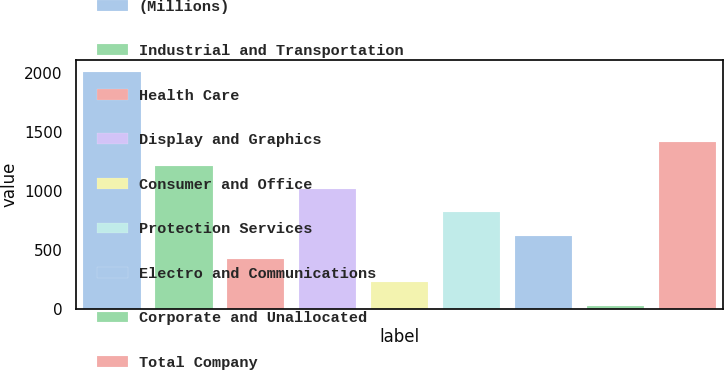<chart> <loc_0><loc_0><loc_500><loc_500><bar_chart><fcel>(Millions)<fcel>Industrial and Transportation<fcel>Health Care<fcel>Display and Graphics<fcel>Consumer and Office<fcel>Protection Services<fcel>Electro and Communications<fcel>Corporate and Unallocated<fcel>Total Company<nl><fcel>2007<fcel>1215.8<fcel>424.6<fcel>1018<fcel>226.8<fcel>820.2<fcel>622.4<fcel>29<fcel>1413.6<nl></chart> 